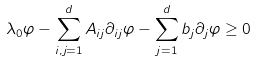Convert formula to latex. <formula><loc_0><loc_0><loc_500><loc_500>\lambda _ { 0 } \varphi - \sum _ { i , j = 1 } ^ { d } A _ { i j } \partial _ { i j } \varphi - \sum _ { j = 1 } ^ { d } b _ { j } \partial _ { j } \varphi \geq 0</formula> 